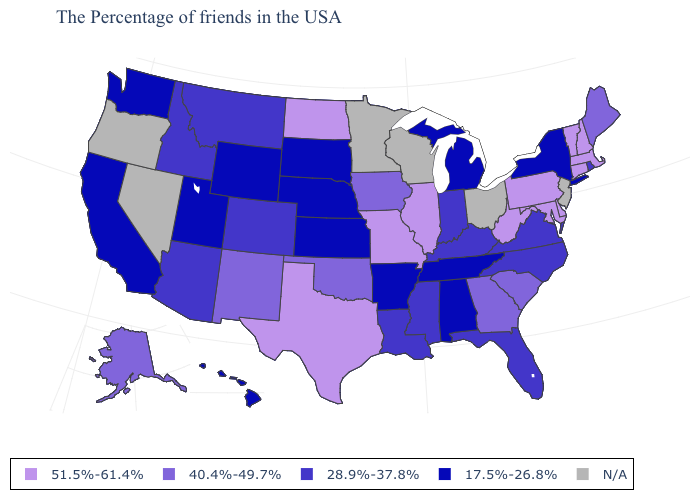What is the value of Mississippi?
Give a very brief answer. 28.9%-37.8%. How many symbols are there in the legend?
Write a very short answer. 5. What is the value of Hawaii?
Write a very short answer. 17.5%-26.8%. Does Massachusetts have the lowest value in the Northeast?
Quick response, please. No. What is the lowest value in the South?
Keep it brief. 17.5%-26.8%. Name the states that have a value in the range 17.5%-26.8%?
Give a very brief answer. New York, Michigan, Alabama, Tennessee, Arkansas, Kansas, Nebraska, South Dakota, Wyoming, Utah, California, Washington, Hawaii. What is the lowest value in the South?
Answer briefly. 17.5%-26.8%. Does Colorado have the lowest value in the USA?
Be succinct. No. Name the states that have a value in the range 28.9%-37.8%?
Keep it brief. Rhode Island, Virginia, North Carolina, Florida, Kentucky, Indiana, Mississippi, Louisiana, Colorado, Montana, Arizona, Idaho. Name the states that have a value in the range 40.4%-49.7%?
Answer briefly. Maine, South Carolina, Georgia, Iowa, Oklahoma, New Mexico, Alaska. Which states have the highest value in the USA?
Short answer required. Massachusetts, New Hampshire, Vermont, Connecticut, Delaware, Maryland, Pennsylvania, West Virginia, Illinois, Missouri, Texas, North Dakota. What is the value of Minnesota?
Concise answer only. N/A. Which states have the lowest value in the MidWest?
Write a very short answer. Michigan, Kansas, Nebraska, South Dakota. What is the lowest value in states that border New York?
Concise answer only. 51.5%-61.4%. 